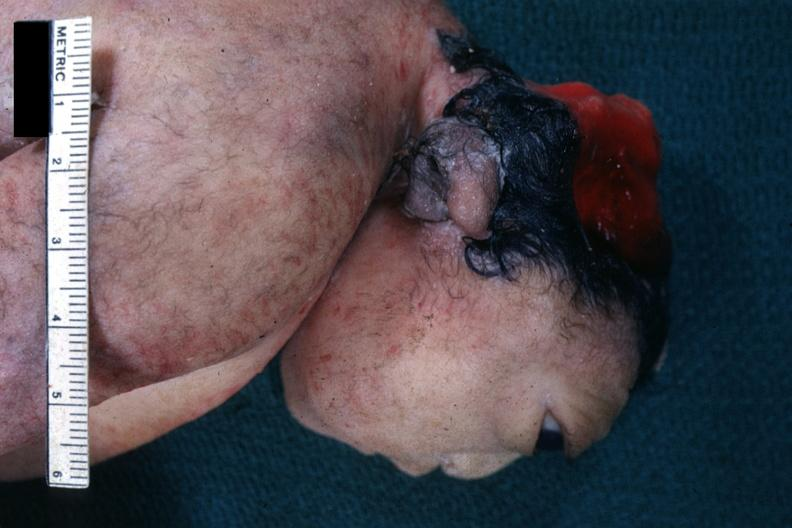what does this image show?
Answer the question using a single word or phrase. Lateral view of head typical example 